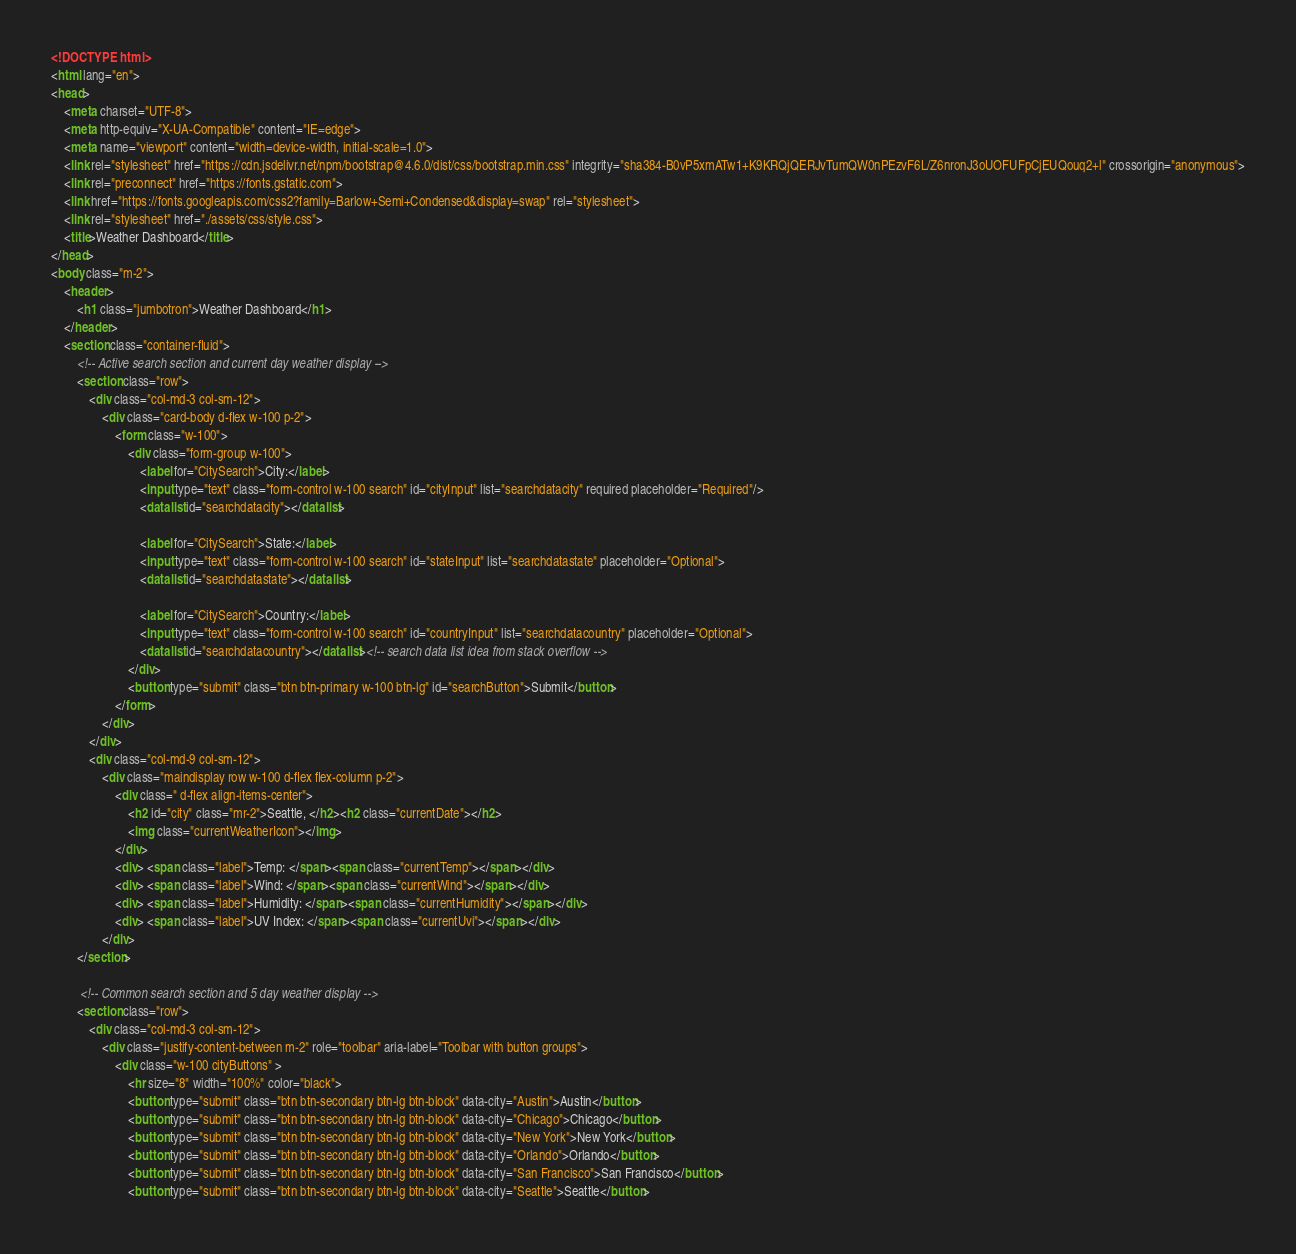<code> <loc_0><loc_0><loc_500><loc_500><_HTML_><!DOCTYPE html>
<html lang="en">
<head>
    <meta charset="UTF-8">
    <meta http-equiv="X-UA-Compatible" content="IE=edge">
    <meta name="viewport" content="width=device-width, initial-scale=1.0">
    <link rel="stylesheet" href="https://cdn.jsdelivr.net/npm/bootstrap@4.6.0/dist/css/bootstrap.min.css" integrity="sha384-B0vP5xmATw1+K9KRQjQERJvTumQW0nPEzvF6L/Z6nronJ3oUOFUFpCjEUQouq2+l" crossorigin="anonymous">
    <link rel="preconnect" href="https://fonts.gstatic.com">
    <link href="https://fonts.googleapis.com/css2?family=Barlow+Semi+Condensed&display=swap" rel="stylesheet">
    <link rel="stylesheet" href="./assets/css/style.css">
    <title>Weather Dashboard</title>
</head>
<body class="m-2">
    <header>
        <h1 class="jumbotron">Weather Dashboard</h1>
    </header>
    <section class="container-fluid">
        <!-- Active search section and current day weather display -->
        <section class="row">
            <div class="col-md-3 col-sm-12">
                <div class="card-body d-flex w-100 p-2">
                    <form class="w-100">
                        <div class="form-group w-100">
                            <label for="CitySearch">City:</label>
                            <input type="text" class="form-control w-100 search" id="cityInput" list="searchdatacity" required placeholder="Required"/>
                            <datalist id="searchdatacity"></datalist>
                            
                            <label for="CitySearch">State:</label>
                            <input type="text" class="form-control w-100 search" id="stateInput" list="searchdatastate" placeholder="Optional">
                            <datalist id="searchdatastate"></datalist>
                            
                            <label for="CitySearch">Country:</label>
                            <input type="text" class="form-control w-100 search" id="countryInput" list="searchdatacountry" placeholder="Optional">
                            <datalist id="searchdatacountry"></datalist><!-- search data list idea from stack overflow -->
                        </div>
                        <button type="submit" class="btn btn-primary w-100 btn-lg" id="searchButton">Submit</button>
                    </form>
                </div>
            </div>
            <div class="col-md-9 col-sm-12">
                <div class="maindisplay row w-100 d-flex flex-column p-2">
                    <div class=" d-flex align-items-center">
                        <h2 id="city" class="mr-2">Seattle, </h2><h2 class="currentDate"></h2>
                        <img class="currentWeatherIcon"></img>
                    </div>
                    <div> <span class="label">Temp: </span><span class="currentTemp"></span></div>
                    <div> <span class="label">Wind: </span><span class="currentWind"></span></div>
                    <div> <span class="label">Humidity: </span><span class="currentHumidity"></span></div> 
                    <div> <span class="label">UV Index: </span><span class="currentUvi"></span></div> 
                </div>
        </section>
        
         <!-- Common search section and 5 day weather display -->
        <section class="row">
            <div class="col-md-3 col-sm-12">
                <div class="justify-content-between m-2" role="toolbar" aria-label="Toolbar with button groups">
                    <div class="w-100 cityButtons" >
                        <hr size="8" width="100%" color="black">
                        <button type="submit" class="btn btn-secondary btn-lg btn-block" data-city="Austin">Austin</button>
                        <button type="submit" class="btn btn-secondary btn-lg btn-block" data-city="Chicago">Chicago</button>
                        <button type="submit" class="btn btn-secondary btn-lg btn-block" data-city="New York">New York</button>
                        <button type="submit" class="btn btn-secondary btn-lg btn-block" data-city="Orlando">Orlando</button>
                        <button type="submit" class="btn btn-secondary btn-lg btn-block" data-city="San Francisco">San Francisco</button>
                        <button type="submit" class="btn btn-secondary btn-lg btn-block" data-city="Seattle">Seattle</button></code> 